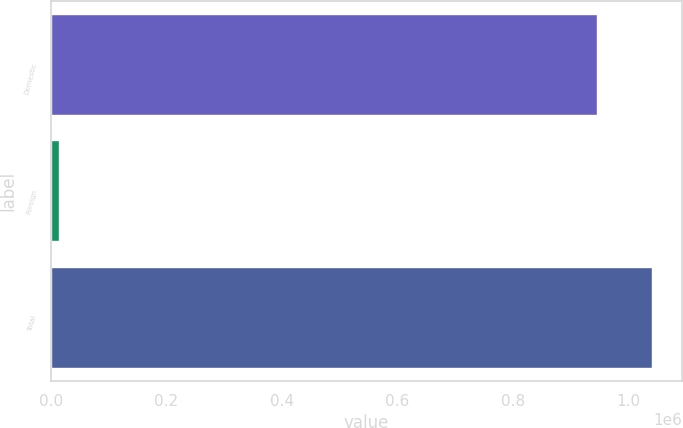Convert chart. <chart><loc_0><loc_0><loc_500><loc_500><bar_chart><fcel>Domestic<fcel>Foreign<fcel>Total<nl><fcel>946592<fcel>14920<fcel>1.04125e+06<nl></chart> 